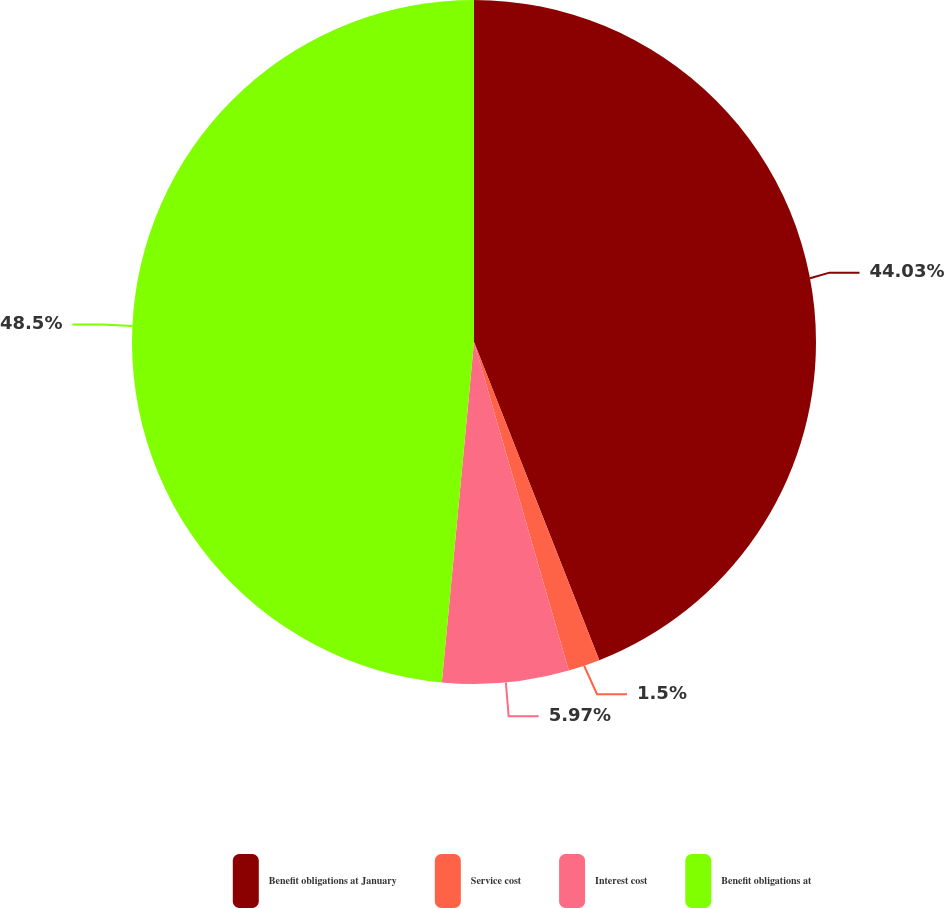Convert chart to OTSL. <chart><loc_0><loc_0><loc_500><loc_500><pie_chart><fcel>Benefit obligations at January<fcel>Service cost<fcel>Interest cost<fcel>Benefit obligations at<nl><fcel>44.03%<fcel>1.5%<fcel>5.97%<fcel>48.5%<nl></chart> 